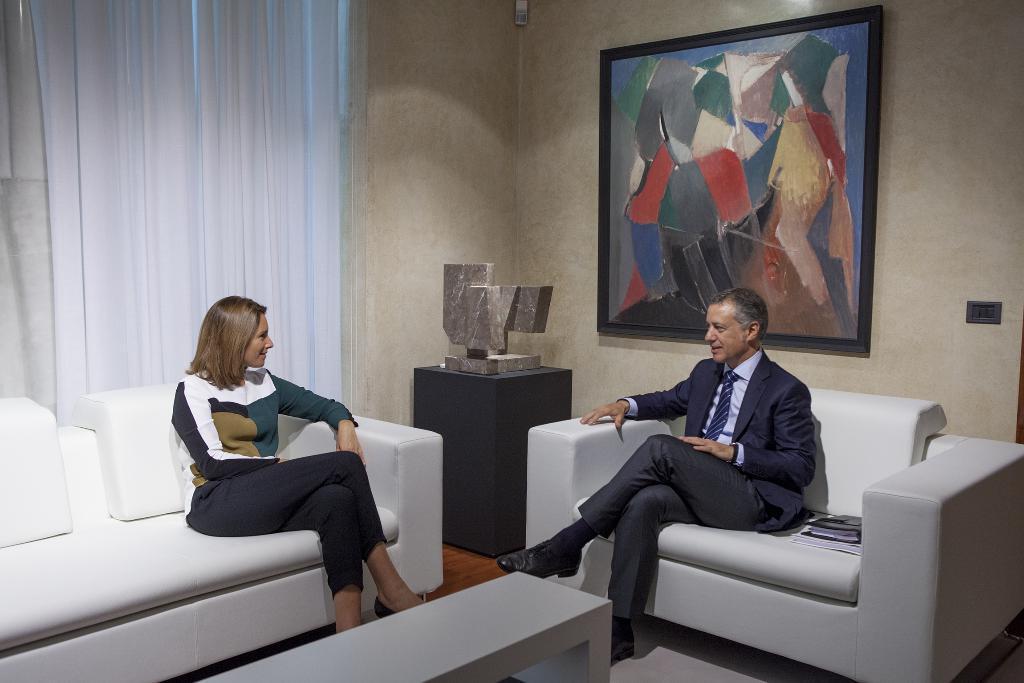Please provide a concise description of this image. This image is clicked in a room there are two sofas in the middle of the room. Man is sitting on the right side and woman is sitting on the left side. Woman is wearing black pant and multi colored shirt. Man is wearing blazer and black pant with a tie. There is also a book placed beside man. There is wall painting on the right side and on the top of the man. Behind woman there is a curtain which is in white color, there is also a table in front of them. 